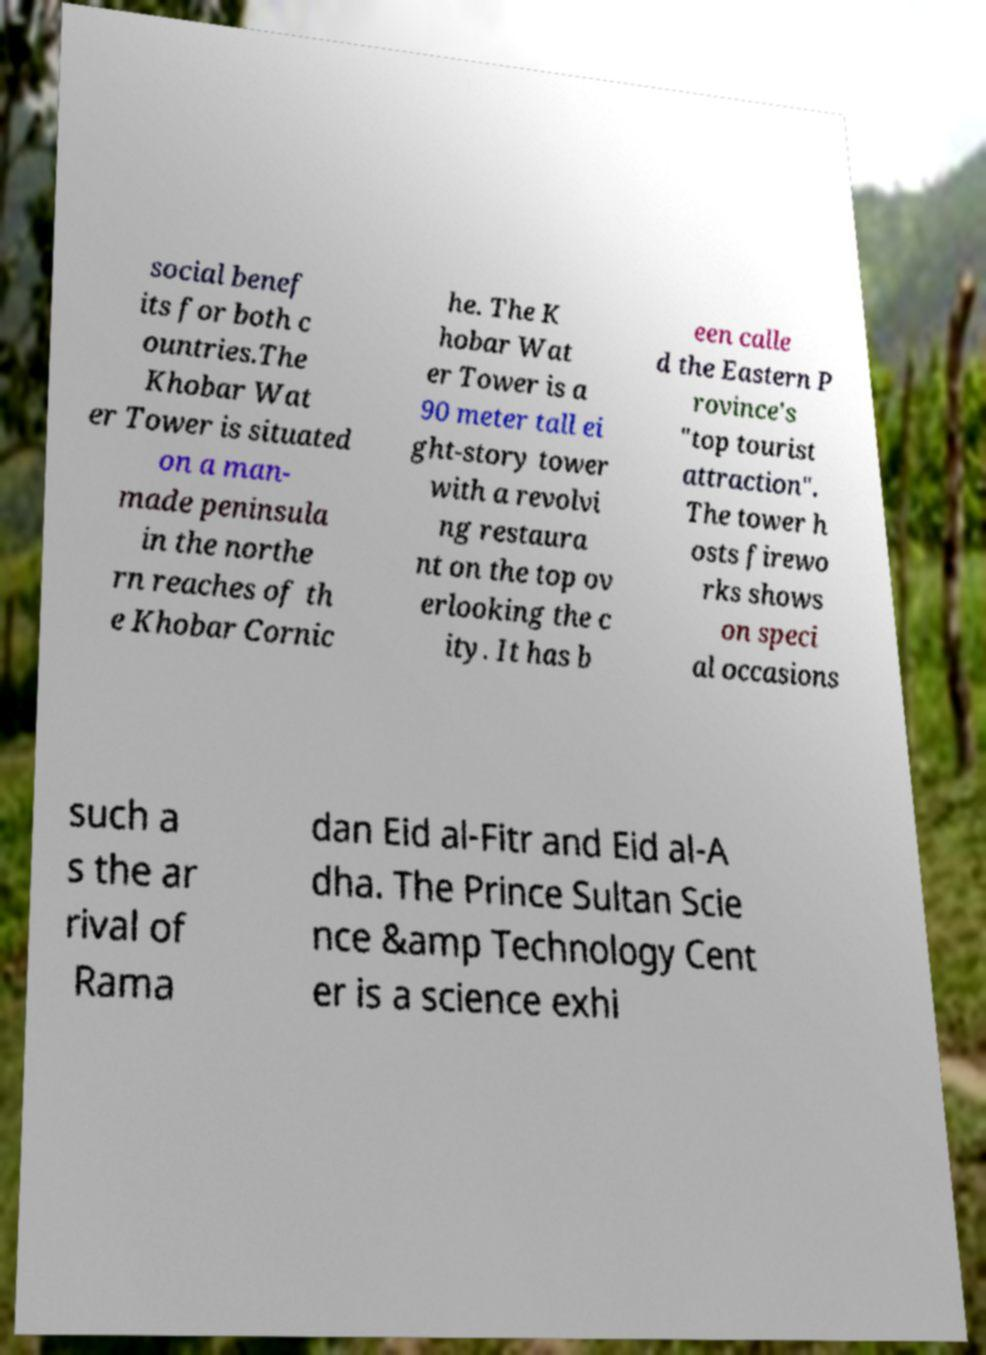For documentation purposes, I need the text within this image transcribed. Could you provide that? social benef its for both c ountries.The Khobar Wat er Tower is situated on a man- made peninsula in the northe rn reaches of th e Khobar Cornic he. The K hobar Wat er Tower is a 90 meter tall ei ght-story tower with a revolvi ng restaura nt on the top ov erlooking the c ity. It has b een calle d the Eastern P rovince's "top tourist attraction". The tower h osts firewo rks shows on speci al occasions such a s the ar rival of Rama dan Eid al-Fitr and Eid al-A dha. The Prince Sultan Scie nce &amp Technology Cent er is a science exhi 